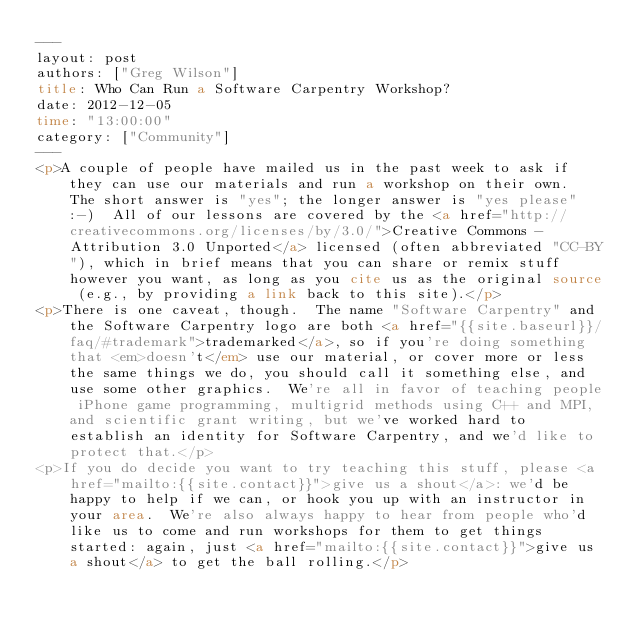<code> <loc_0><loc_0><loc_500><loc_500><_HTML_>---
layout: post
authors: ["Greg Wilson"]
title: Who Can Run a Software Carpentry Workshop?
date: 2012-12-05
time: "13:00:00"
category: ["Community"]
---
<p>A couple of people have mailed us in the past week to ask if they can use our materials and run a workshop on their own.  The short answer is "yes"; the longer answer is "yes please" :-)  All of our lessons are covered by the <a href="http://creativecommons.org/licenses/by/3.0/">Creative Commons - Attribution 3.0 Unported</a> licensed (often abbreviated "CC-BY"), which in brief means that you can share or remix stuff however you want, as long as you cite us as the original source (e.g., by providing a link back to this site).</p>
<p>There is one caveat, though.  The name "Software Carpentry" and the Software Carpentry logo are both <a href="{{site.baseurl}}/faq/#trademark">trademarked</a>, so if you're doing something that <em>doesn't</em> use our material, or cover more or less the same things we do, you should call it something else, and use some other graphics.  We're all in favor of teaching people iPhone game programming, multigrid methods using C++ and MPI, and scientific grant writing, but we've worked hard to establish an identity for Software Carpentry, and we'd like to protect that.</p>
<p>If you do decide you want to try teaching this stuff, please <a href="mailto:{{site.contact}}">give us a shout</a>: we'd be happy to help if we can, or hook you up with an instructor in your area.  We're also always happy to hear from people who'd like us to come and run workshops for them to get things started: again, just <a href="mailto:{{site.contact}}">give us a shout</a> to get the ball rolling.</p>
</code> 